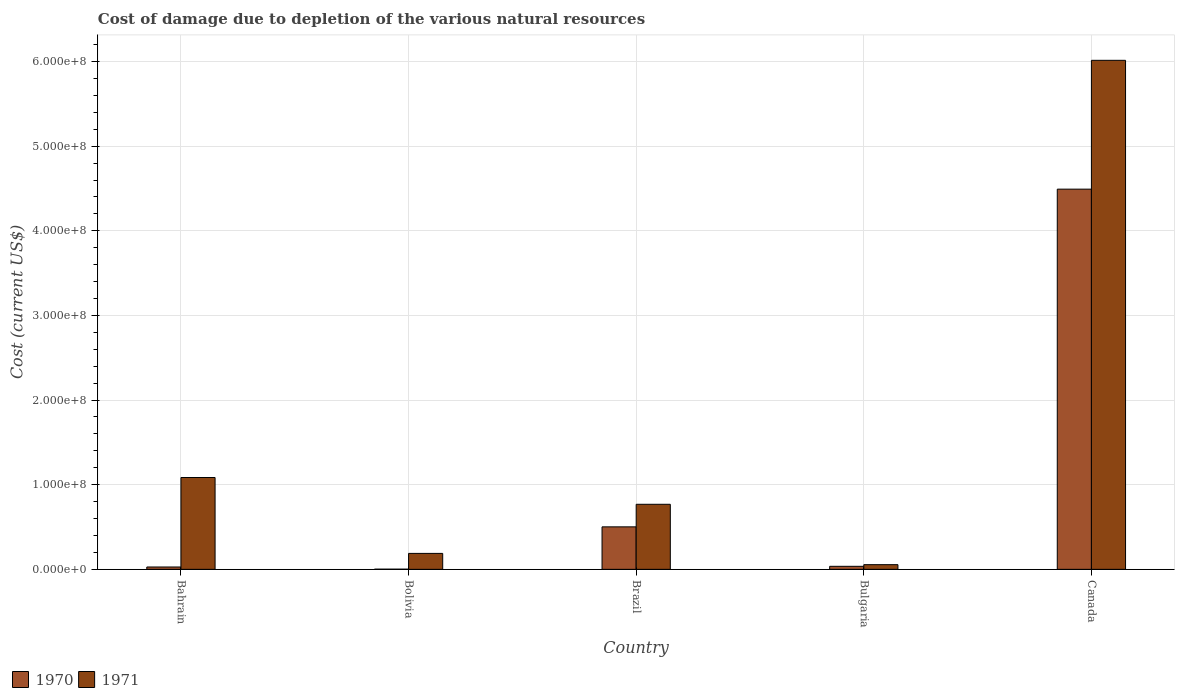How many different coloured bars are there?
Offer a terse response. 2. How many groups of bars are there?
Offer a very short reply. 5. Are the number of bars on each tick of the X-axis equal?
Your answer should be compact. Yes. How many bars are there on the 5th tick from the left?
Offer a terse response. 2. What is the label of the 3rd group of bars from the left?
Your answer should be compact. Brazil. What is the cost of damage caused due to the depletion of various natural resources in 1971 in Bolivia?
Make the answer very short. 1.88e+07. Across all countries, what is the maximum cost of damage caused due to the depletion of various natural resources in 1971?
Ensure brevity in your answer.  6.01e+08. Across all countries, what is the minimum cost of damage caused due to the depletion of various natural resources in 1971?
Your response must be concise. 5.51e+06. In which country was the cost of damage caused due to the depletion of various natural resources in 1970 maximum?
Offer a terse response. Canada. What is the total cost of damage caused due to the depletion of various natural resources in 1970 in the graph?
Offer a terse response. 5.06e+08. What is the difference between the cost of damage caused due to the depletion of various natural resources in 1971 in Bahrain and that in Brazil?
Your answer should be very brief. 3.16e+07. What is the difference between the cost of damage caused due to the depletion of various natural resources in 1970 in Brazil and the cost of damage caused due to the depletion of various natural resources in 1971 in Bahrain?
Keep it short and to the point. -5.83e+07. What is the average cost of damage caused due to the depletion of various natural resources in 1971 per country?
Your answer should be very brief. 1.62e+08. What is the difference between the cost of damage caused due to the depletion of various natural resources of/in 1971 and cost of damage caused due to the depletion of various natural resources of/in 1970 in Bulgaria?
Your answer should be very brief. 1.95e+06. In how many countries, is the cost of damage caused due to the depletion of various natural resources in 1971 greater than 60000000 US$?
Offer a terse response. 3. What is the ratio of the cost of damage caused due to the depletion of various natural resources in 1970 in Bahrain to that in Bulgaria?
Your answer should be compact. 0.78. Is the cost of damage caused due to the depletion of various natural resources in 1970 in Bolivia less than that in Canada?
Make the answer very short. Yes. Is the difference between the cost of damage caused due to the depletion of various natural resources in 1971 in Brazil and Canada greater than the difference between the cost of damage caused due to the depletion of various natural resources in 1970 in Brazil and Canada?
Your response must be concise. No. What is the difference between the highest and the second highest cost of damage caused due to the depletion of various natural resources in 1971?
Offer a very short reply. -4.93e+08. What is the difference between the highest and the lowest cost of damage caused due to the depletion of various natural resources in 1970?
Offer a very short reply. 4.49e+08. What does the 2nd bar from the left in Bolivia represents?
Your answer should be very brief. 1971. How many bars are there?
Offer a terse response. 10. What is the difference between two consecutive major ticks on the Y-axis?
Your response must be concise. 1.00e+08. Does the graph contain any zero values?
Offer a terse response. No. How many legend labels are there?
Ensure brevity in your answer.  2. How are the legend labels stacked?
Ensure brevity in your answer.  Horizontal. What is the title of the graph?
Your answer should be compact. Cost of damage due to depletion of the various natural resources. Does "1996" appear as one of the legend labels in the graph?
Make the answer very short. No. What is the label or title of the X-axis?
Ensure brevity in your answer.  Country. What is the label or title of the Y-axis?
Your answer should be very brief. Cost (current US$). What is the Cost (current US$) of 1970 in Bahrain?
Your answer should be very brief. 2.77e+06. What is the Cost (current US$) in 1971 in Bahrain?
Offer a very short reply. 1.09e+08. What is the Cost (current US$) in 1970 in Bolivia?
Your response must be concise. 1.74e+05. What is the Cost (current US$) of 1971 in Bolivia?
Your answer should be very brief. 1.88e+07. What is the Cost (current US$) of 1970 in Brazil?
Offer a very short reply. 5.02e+07. What is the Cost (current US$) of 1971 in Brazil?
Give a very brief answer. 7.69e+07. What is the Cost (current US$) of 1970 in Bulgaria?
Provide a short and direct response. 3.56e+06. What is the Cost (current US$) in 1971 in Bulgaria?
Your answer should be compact. 5.51e+06. What is the Cost (current US$) of 1970 in Canada?
Provide a short and direct response. 4.49e+08. What is the Cost (current US$) in 1971 in Canada?
Keep it short and to the point. 6.01e+08. Across all countries, what is the maximum Cost (current US$) of 1970?
Make the answer very short. 4.49e+08. Across all countries, what is the maximum Cost (current US$) in 1971?
Provide a succinct answer. 6.01e+08. Across all countries, what is the minimum Cost (current US$) in 1970?
Ensure brevity in your answer.  1.74e+05. Across all countries, what is the minimum Cost (current US$) in 1971?
Keep it short and to the point. 5.51e+06. What is the total Cost (current US$) in 1970 in the graph?
Offer a very short reply. 5.06e+08. What is the total Cost (current US$) in 1971 in the graph?
Your answer should be compact. 8.11e+08. What is the difference between the Cost (current US$) in 1970 in Bahrain and that in Bolivia?
Provide a succinct answer. 2.60e+06. What is the difference between the Cost (current US$) in 1971 in Bahrain and that in Bolivia?
Keep it short and to the point. 8.97e+07. What is the difference between the Cost (current US$) of 1970 in Bahrain and that in Brazil?
Offer a terse response. -4.74e+07. What is the difference between the Cost (current US$) in 1971 in Bahrain and that in Brazil?
Your answer should be very brief. 3.16e+07. What is the difference between the Cost (current US$) of 1970 in Bahrain and that in Bulgaria?
Make the answer very short. -7.93e+05. What is the difference between the Cost (current US$) of 1971 in Bahrain and that in Bulgaria?
Your response must be concise. 1.03e+08. What is the difference between the Cost (current US$) of 1970 in Bahrain and that in Canada?
Ensure brevity in your answer.  -4.46e+08. What is the difference between the Cost (current US$) in 1971 in Bahrain and that in Canada?
Keep it short and to the point. -4.93e+08. What is the difference between the Cost (current US$) of 1970 in Bolivia and that in Brazil?
Provide a succinct answer. -5.00e+07. What is the difference between the Cost (current US$) in 1971 in Bolivia and that in Brazil?
Offer a terse response. -5.80e+07. What is the difference between the Cost (current US$) in 1970 in Bolivia and that in Bulgaria?
Provide a short and direct response. -3.39e+06. What is the difference between the Cost (current US$) of 1971 in Bolivia and that in Bulgaria?
Ensure brevity in your answer.  1.33e+07. What is the difference between the Cost (current US$) of 1970 in Bolivia and that in Canada?
Your response must be concise. -4.49e+08. What is the difference between the Cost (current US$) of 1971 in Bolivia and that in Canada?
Make the answer very short. -5.83e+08. What is the difference between the Cost (current US$) of 1970 in Brazil and that in Bulgaria?
Provide a succinct answer. 4.66e+07. What is the difference between the Cost (current US$) in 1971 in Brazil and that in Bulgaria?
Provide a short and direct response. 7.14e+07. What is the difference between the Cost (current US$) of 1970 in Brazil and that in Canada?
Provide a short and direct response. -3.99e+08. What is the difference between the Cost (current US$) of 1971 in Brazil and that in Canada?
Provide a short and direct response. -5.25e+08. What is the difference between the Cost (current US$) of 1970 in Bulgaria and that in Canada?
Offer a terse response. -4.46e+08. What is the difference between the Cost (current US$) in 1971 in Bulgaria and that in Canada?
Make the answer very short. -5.96e+08. What is the difference between the Cost (current US$) of 1970 in Bahrain and the Cost (current US$) of 1971 in Bolivia?
Offer a terse response. -1.61e+07. What is the difference between the Cost (current US$) in 1970 in Bahrain and the Cost (current US$) in 1971 in Brazil?
Ensure brevity in your answer.  -7.41e+07. What is the difference between the Cost (current US$) in 1970 in Bahrain and the Cost (current US$) in 1971 in Bulgaria?
Provide a short and direct response. -2.74e+06. What is the difference between the Cost (current US$) in 1970 in Bahrain and the Cost (current US$) in 1971 in Canada?
Offer a terse response. -5.99e+08. What is the difference between the Cost (current US$) of 1970 in Bolivia and the Cost (current US$) of 1971 in Brazil?
Keep it short and to the point. -7.67e+07. What is the difference between the Cost (current US$) of 1970 in Bolivia and the Cost (current US$) of 1971 in Bulgaria?
Your answer should be very brief. -5.33e+06. What is the difference between the Cost (current US$) of 1970 in Bolivia and the Cost (current US$) of 1971 in Canada?
Keep it short and to the point. -6.01e+08. What is the difference between the Cost (current US$) in 1970 in Brazil and the Cost (current US$) in 1971 in Bulgaria?
Give a very brief answer. 4.47e+07. What is the difference between the Cost (current US$) in 1970 in Brazil and the Cost (current US$) in 1971 in Canada?
Offer a very short reply. -5.51e+08. What is the difference between the Cost (current US$) in 1970 in Bulgaria and the Cost (current US$) in 1971 in Canada?
Your response must be concise. -5.98e+08. What is the average Cost (current US$) in 1970 per country?
Your answer should be very brief. 1.01e+08. What is the average Cost (current US$) of 1971 per country?
Offer a terse response. 1.62e+08. What is the difference between the Cost (current US$) of 1970 and Cost (current US$) of 1971 in Bahrain?
Give a very brief answer. -1.06e+08. What is the difference between the Cost (current US$) of 1970 and Cost (current US$) of 1971 in Bolivia?
Ensure brevity in your answer.  -1.86e+07. What is the difference between the Cost (current US$) of 1970 and Cost (current US$) of 1971 in Brazil?
Your answer should be very brief. -2.67e+07. What is the difference between the Cost (current US$) in 1970 and Cost (current US$) in 1971 in Bulgaria?
Provide a short and direct response. -1.95e+06. What is the difference between the Cost (current US$) in 1970 and Cost (current US$) in 1971 in Canada?
Offer a very short reply. -1.52e+08. What is the ratio of the Cost (current US$) of 1970 in Bahrain to that in Bolivia?
Give a very brief answer. 15.88. What is the ratio of the Cost (current US$) of 1971 in Bahrain to that in Bolivia?
Provide a short and direct response. 5.77. What is the ratio of the Cost (current US$) of 1970 in Bahrain to that in Brazil?
Your response must be concise. 0.06. What is the ratio of the Cost (current US$) of 1971 in Bahrain to that in Brazil?
Keep it short and to the point. 1.41. What is the ratio of the Cost (current US$) of 1970 in Bahrain to that in Bulgaria?
Give a very brief answer. 0.78. What is the ratio of the Cost (current US$) of 1971 in Bahrain to that in Bulgaria?
Give a very brief answer. 19.7. What is the ratio of the Cost (current US$) in 1970 in Bahrain to that in Canada?
Provide a succinct answer. 0.01. What is the ratio of the Cost (current US$) of 1971 in Bahrain to that in Canada?
Your answer should be very brief. 0.18. What is the ratio of the Cost (current US$) in 1970 in Bolivia to that in Brazil?
Offer a terse response. 0. What is the ratio of the Cost (current US$) of 1971 in Bolivia to that in Brazil?
Provide a succinct answer. 0.24. What is the ratio of the Cost (current US$) in 1970 in Bolivia to that in Bulgaria?
Provide a short and direct response. 0.05. What is the ratio of the Cost (current US$) of 1971 in Bolivia to that in Bulgaria?
Your answer should be very brief. 3.42. What is the ratio of the Cost (current US$) of 1970 in Bolivia to that in Canada?
Your answer should be very brief. 0. What is the ratio of the Cost (current US$) of 1971 in Bolivia to that in Canada?
Offer a very short reply. 0.03. What is the ratio of the Cost (current US$) in 1970 in Brazil to that in Bulgaria?
Provide a short and direct response. 14.09. What is the ratio of the Cost (current US$) of 1971 in Brazil to that in Bulgaria?
Your answer should be compact. 13.95. What is the ratio of the Cost (current US$) of 1970 in Brazil to that in Canada?
Ensure brevity in your answer.  0.11. What is the ratio of the Cost (current US$) of 1971 in Brazil to that in Canada?
Your response must be concise. 0.13. What is the ratio of the Cost (current US$) of 1970 in Bulgaria to that in Canada?
Make the answer very short. 0.01. What is the ratio of the Cost (current US$) in 1971 in Bulgaria to that in Canada?
Ensure brevity in your answer.  0.01. What is the difference between the highest and the second highest Cost (current US$) of 1970?
Make the answer very short. 3.99e+08. What is the difference between the highest and the second highest Cost (current US$) in 1971?
Your answer should be very brief. 4.93e+08. What is the difference between the highest and the lowest Cost (current US$) of 1970?
Keep it short and to the point. 4.49e+08. What is the difference between the highest and the lowest Cost (current US$) in 1971?
Ensure brevity in your answer.  5.96e+08. 